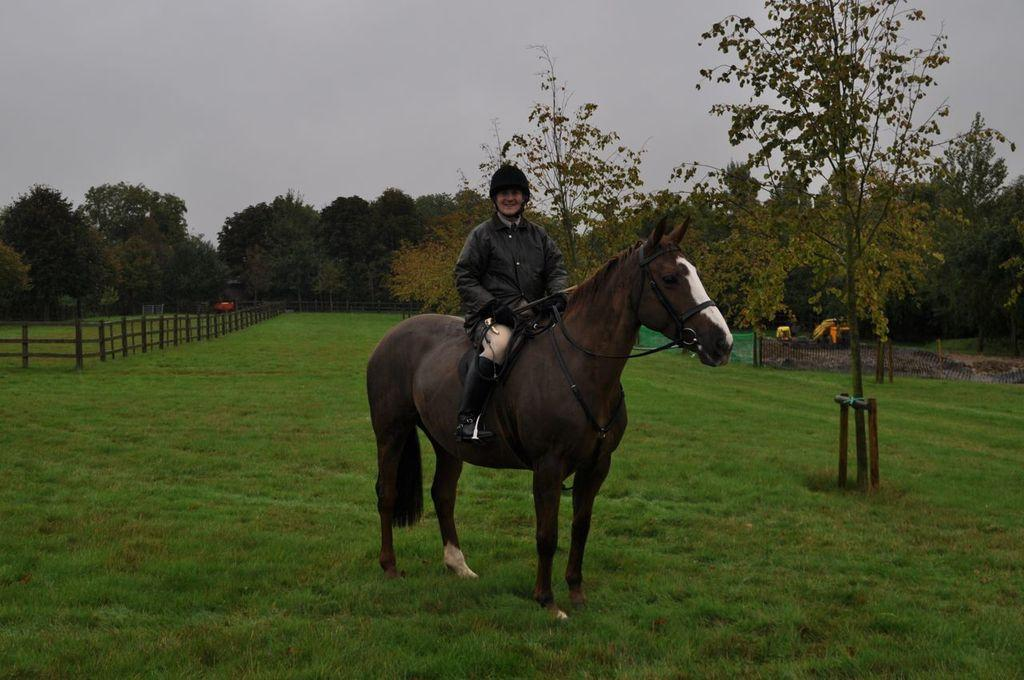What is the main subject of the image? There is a person riding a horse in the image. What can be seen on the ground in the image? The ground is visible in the image, with some grass, and there are a few objects on the ground. What type of barrier is present in the image? There is a fence in the image. What type of vegetation is present in the image? There are a few trees in the image. What is visible above the ground in the image? The sky is visible in the image. How does the person riding the horse use the brake in the image? There is no brake present in the image, as the person is riding a horse, not a vehicle with brakes. 